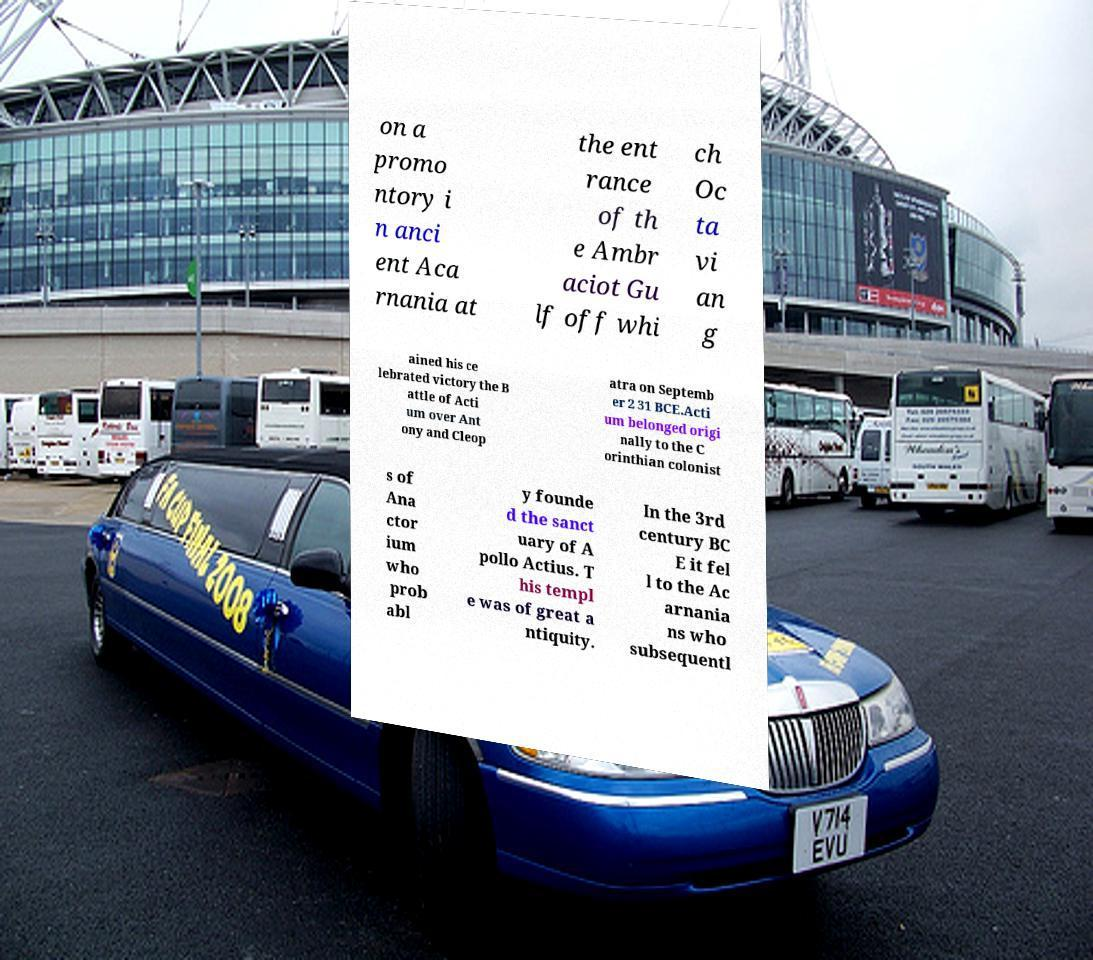Can you accurately transcribe the text from the provided image for me? on a promo ntory i n anci ent Aca rnania at the ent rance of th e Ambr aciot Gu lf off whi ch Oc ta vi an g ained his ce lebrated victory the B attle of Acti um over Ant ony and Cleop atra on Septemb er 2 31 BCE.Acti um belonged origi nally to the C orinthian colonist s of Ana ctor ium who prob abl y founde d the sanct uary of A pollo Actius. T his templ e was of great a ntiquity. In the 3rd century BC E it fel l to the Ac arnania ns who subsequentl 